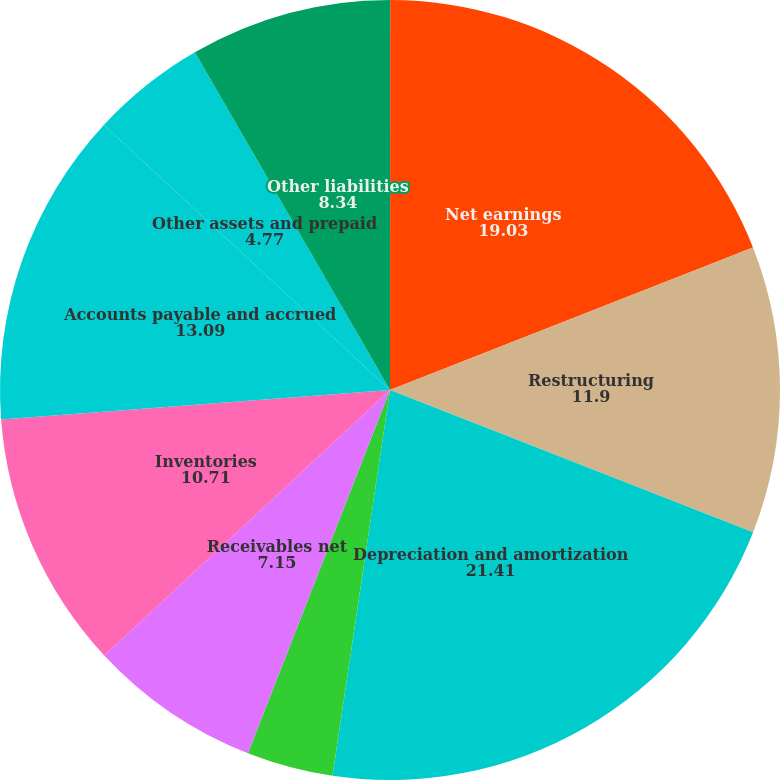Convert chart. <chart><loc_0><loc_0><loc_500><loc_500><pie_chart><fcel>(In thousands)<fcel>Net earnings<fcel>Restructuring<fcel>Depreciation and amortization<fcel>Deferred income taxes<fcel>Receivables net<fcel>Inventories<fcel>Accounts payable and accrued<fcel>Other assets and prepaid<fcel>Other liabilities<nl><fcel>0.01%<fcel>19.03%<fcel>11.9%<fcel>21.41%<fcel>3.58%<fcel>7.15%<fcel>10.71%<fcel>13.09%<fcel>4.77%<fcel>8.34%<nl></chart> 